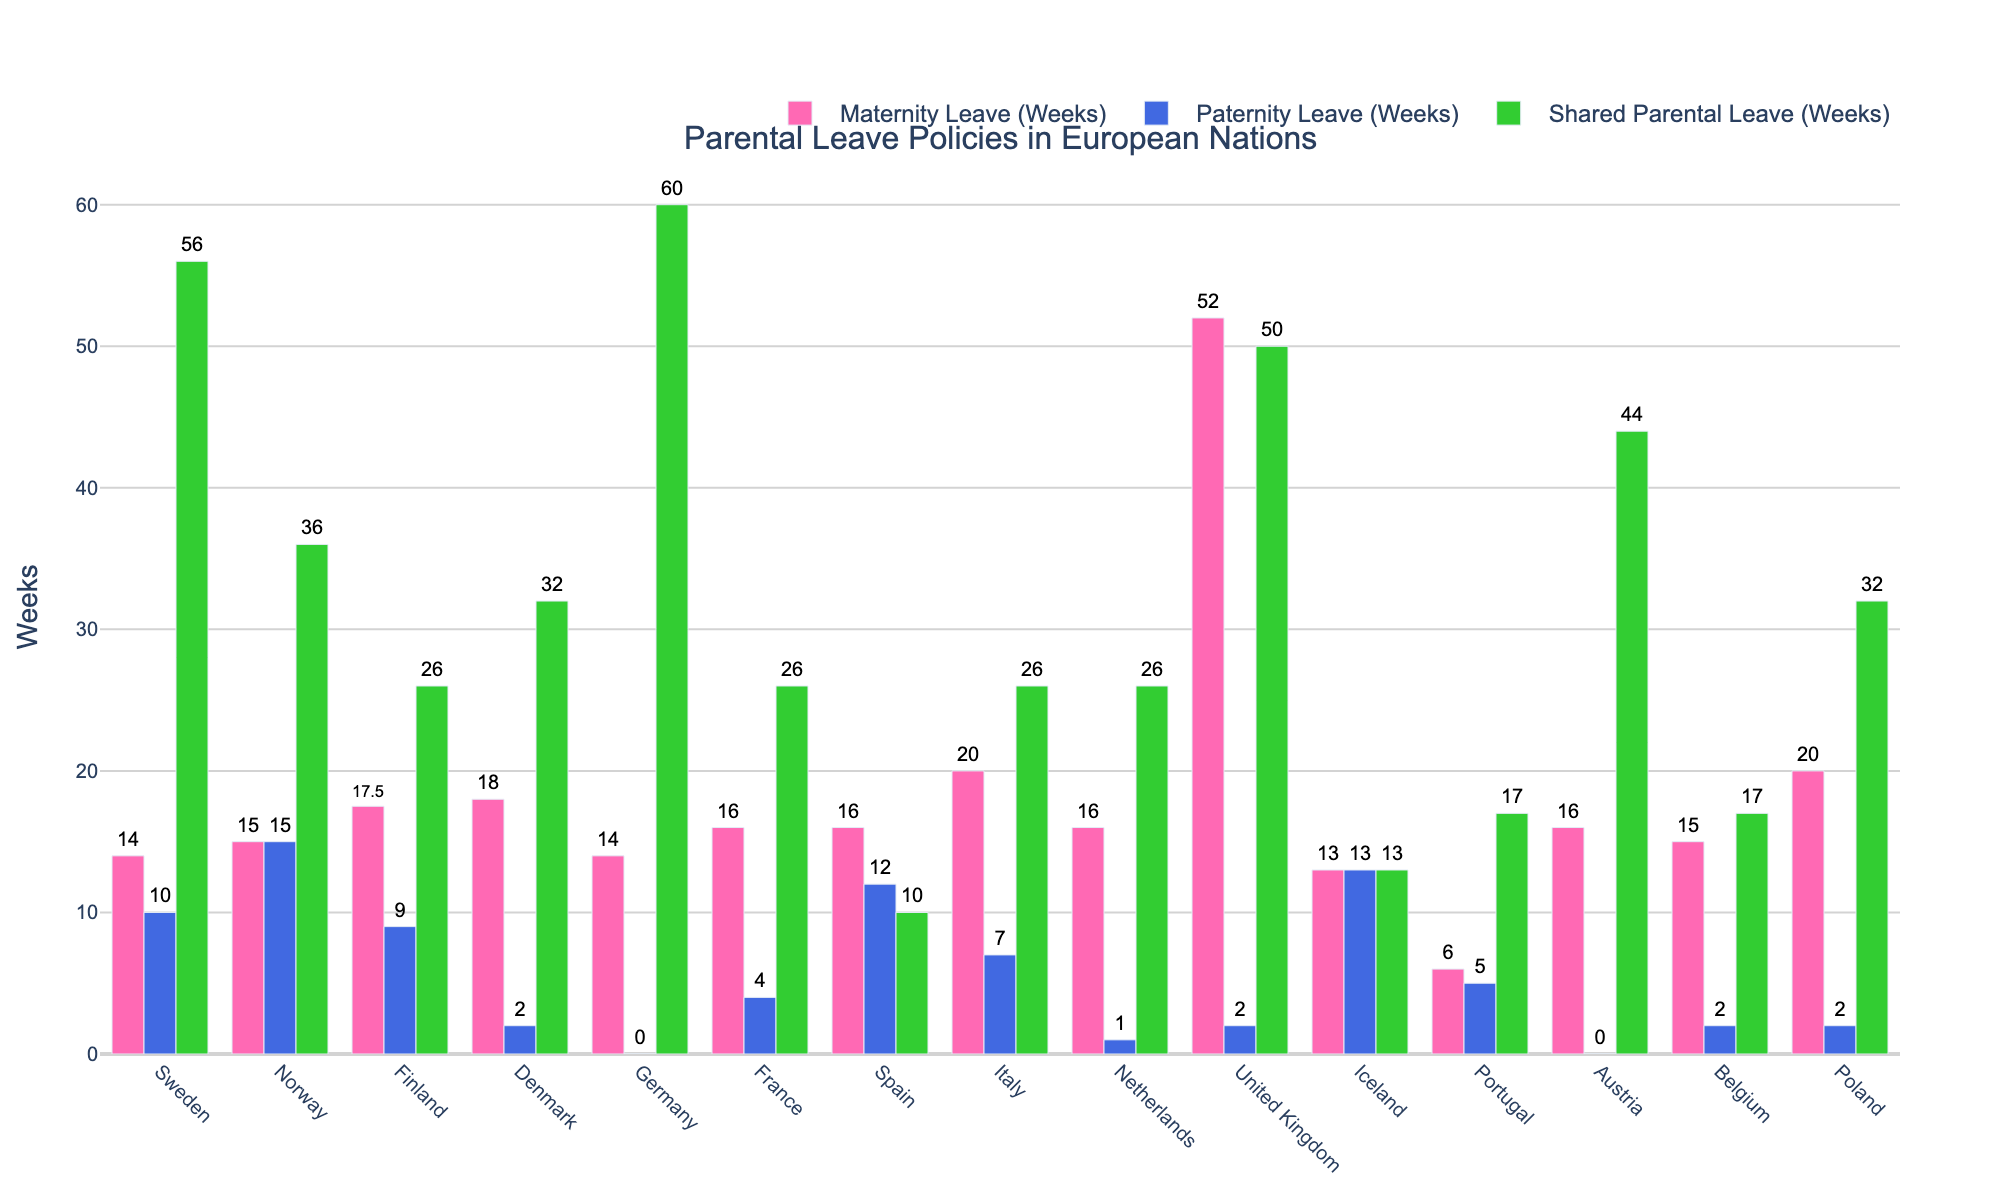Which country offers the longest maternity leave? From the figure, the United Kingdom offers the longest maternity leave with 52 weeks. This bar is the tallest among the maternity leave bars.
Answer: United Kingdom How much longer is maternity leave compared to paternity leave in Italy? The maternity leave in Italy is 20 weeks, and the paternity leave is 7 weeks. Calculating the difference, 20 - 7 = 13 weeks.
Answer: 13 weeks Which country has equal amounts of maternity and paternity leave, and how many weeks are allocated for each? Iceland offers equal amounts of maternity and paternity leave. Both bars are the same height, showing 13 weeks each.
Answer: Iceland, 13 weeks What is the total parental leave (sum of maternity, paternity, and shared parental leave) in Germany? In Germany, the maternity leave is 14 weeks, paternity leave is 0 weeks, and shared parental leave is 60 weeks. Summing these up: 14 + 0 + 60 = 74 weeks.
Answer: 74 weeks Which countries have no paternity leave? Germany and Austria have no paternity leave, as indicated by the absence of a bar for paternity leave in these countries.
Answer: Germany, Austria Compare and contrast the shared parental leave in Denmark and Sweden. Denmark offers 32 weeks of shared parental leave, whereas Sweden offers significantly more with 56 weeks. This difference is visually represented by the taller bar for shared parental leave in Sweden compared to that in Denmark.
Answer: Sweden has 24 weeks more than Denmark Which country has the shortest shared parental leave, and how many weeks is it? Spain has the shortest shared parental leave at 10 weeks, shown by the shortest bar in the shared parental leave category.
Answer: Spain, 10 weeks Is maternity leave generally longer, shorter, or equal to paternity leave across all countries? By observing the heights of maternity and paternity leave bars across most countries, maternity leave is generally longer than paternity leave, except in a few cases like Norway and Iceland where they are equal.
Answer: Longer What is the visual relationship between the colors used in the figure for different types of parental leave? The bars representing maternity leave are pink, paternity leave bars are blue, and shared parental leave bars are green, highlighting different categories visually.
Answer: Pink for maternity, blue for paternity, green for shared parental leave How does shared parental leave in the United Kingdom compare with Austria? The United Kingdom offers 50 weeks of shared parental leave, while Austria offers 44 weeks. The bars for shared parental leave in both countries show that the UK's bar is slightly taller than Austria's.
Answer: The UK has 6 weeks more 